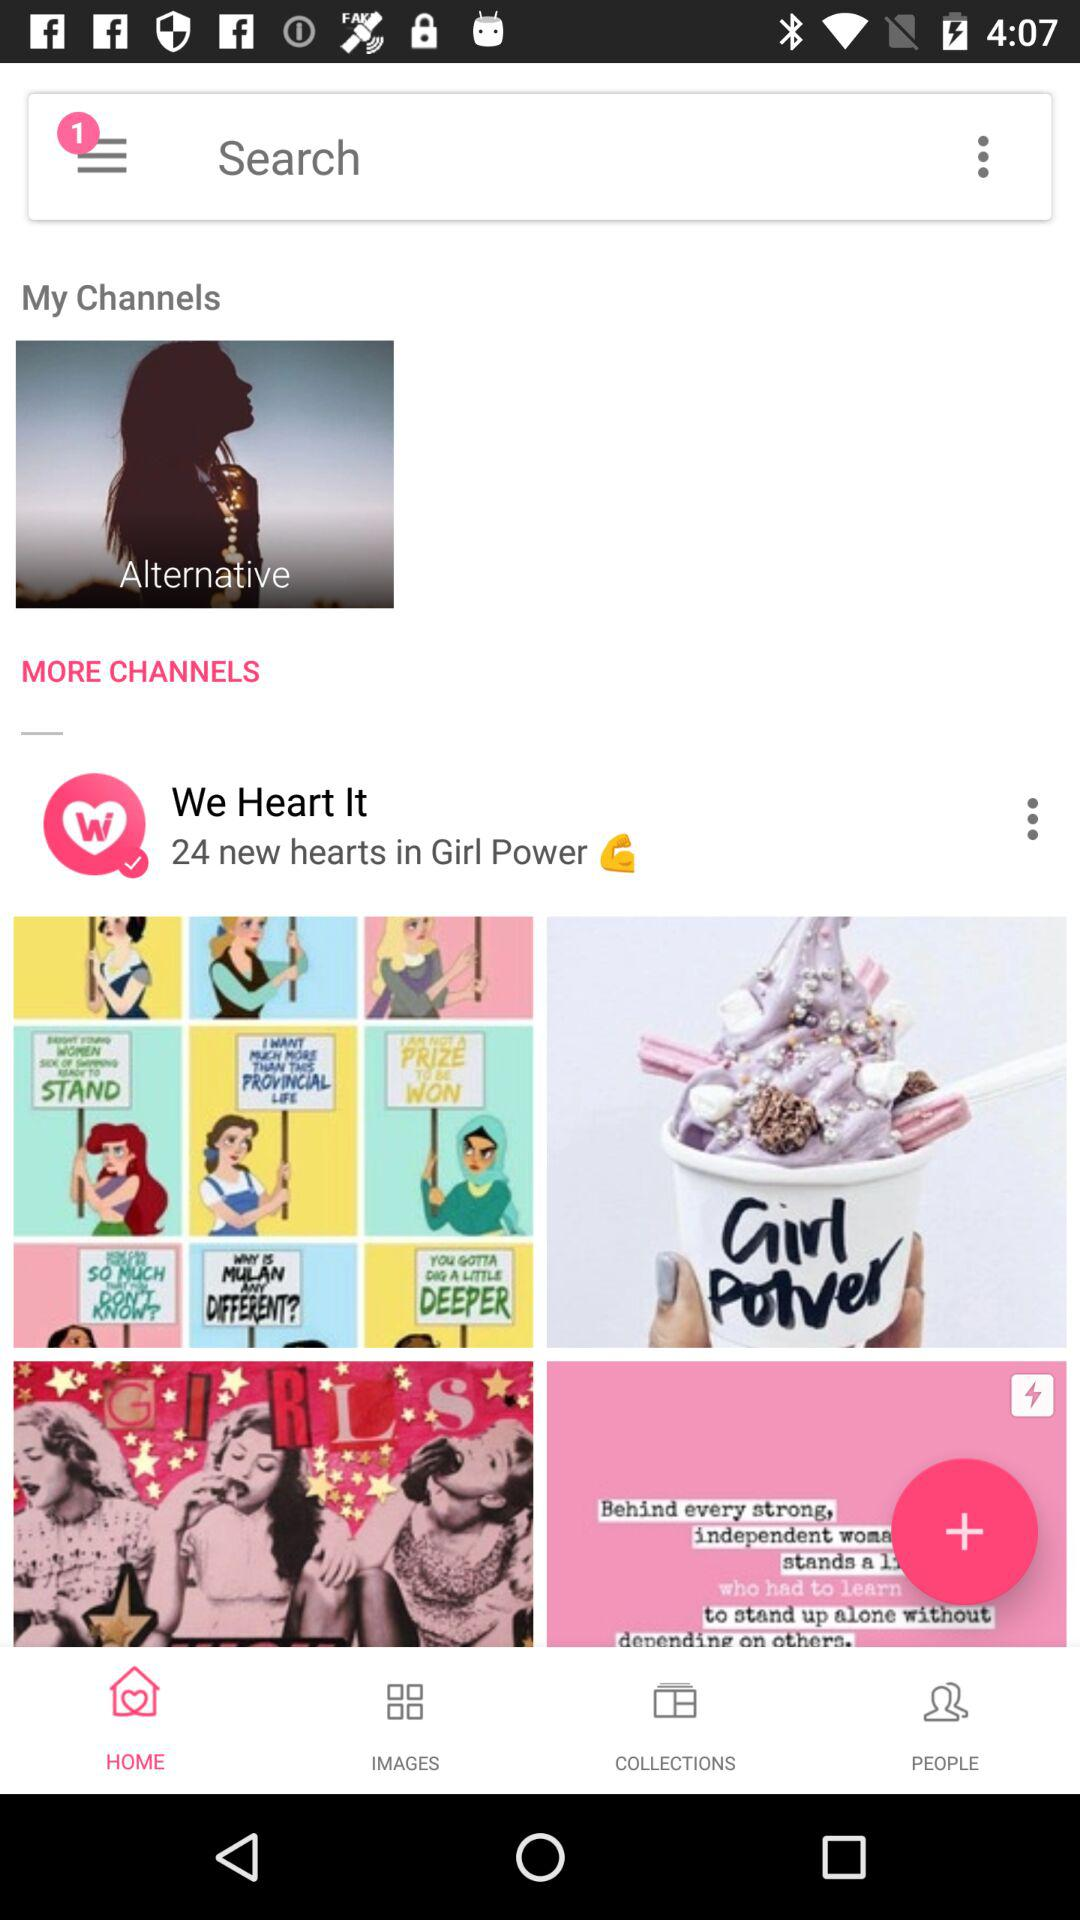Which option is selected? The selected option is "HOME". 